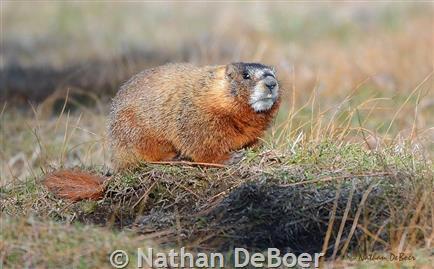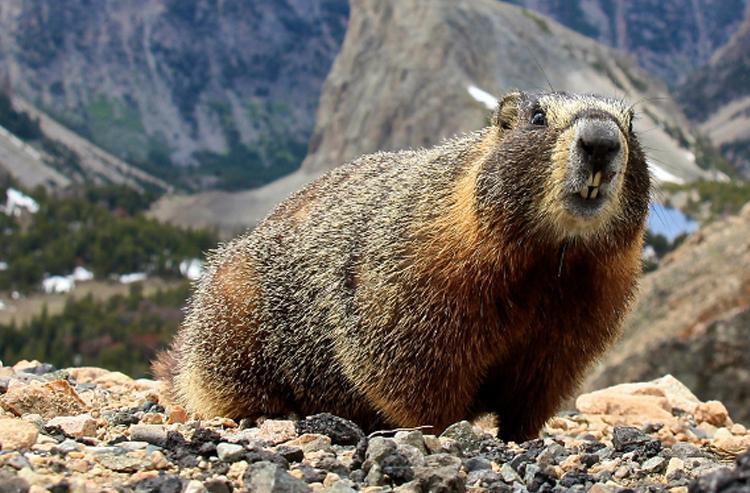The first image is the image on the left, the second image is the image on the right. Analyze the images presented: Is the assertion "An image shows an upright rodent-type animal." valid? Answer yes or no. No. 